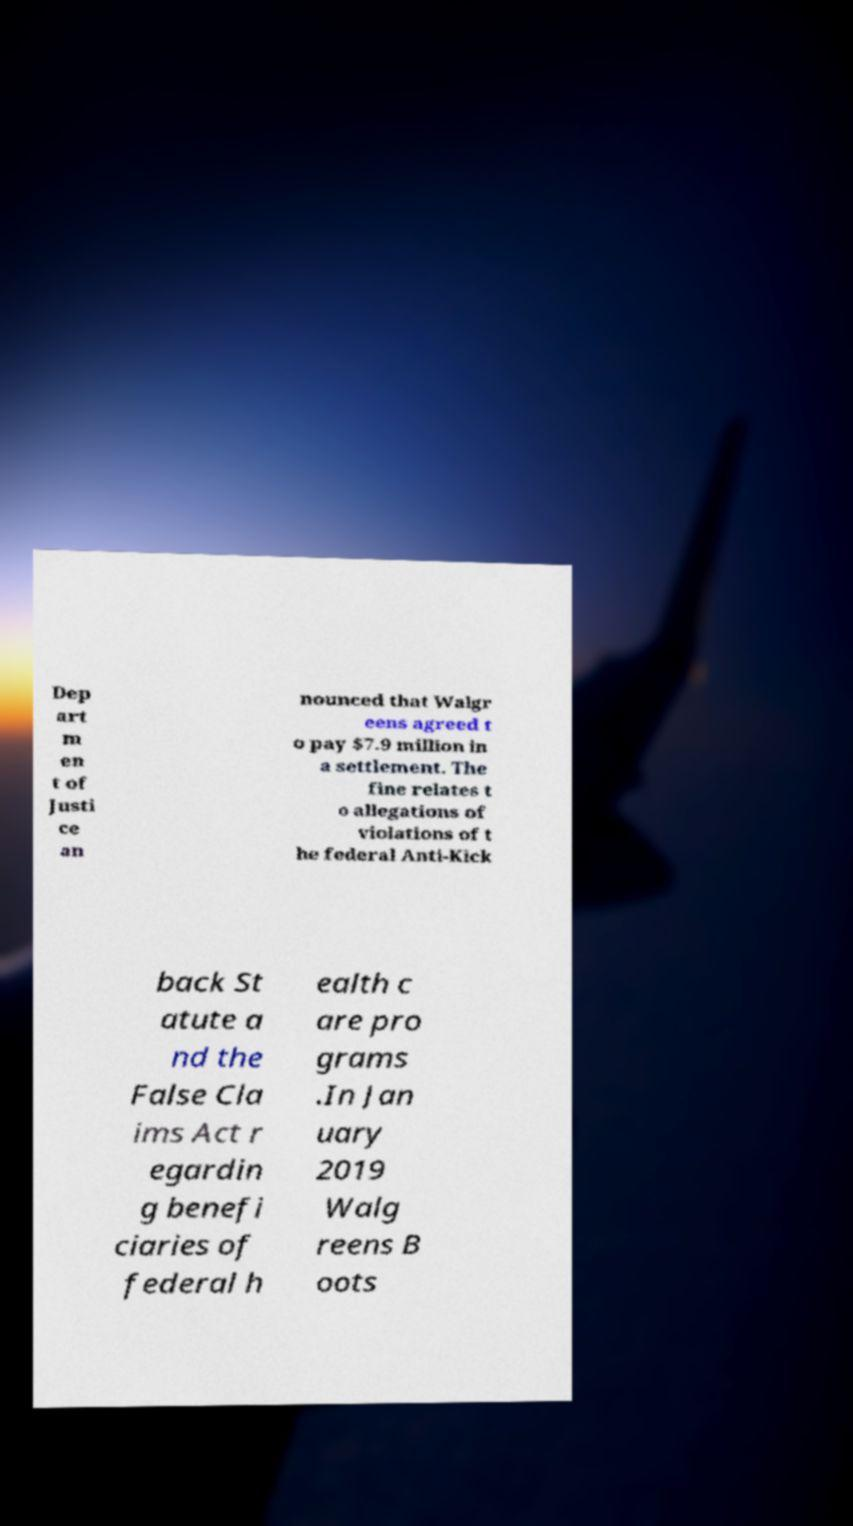For documentation purposes, I need the text within this image transcribed. Could you provide that? Dep art m en t of Justi ce an nounced that Walgr eens agreed t o pay $7.9 million in a settlement. The fine relates t o allegations of violations of t he federal Anti-Kick back St atute a nd the False Cla ims Act r egardin g benefi ciaries of federal h ealth c are pro grams .In Jan uary 2019 Walg reens B oots 